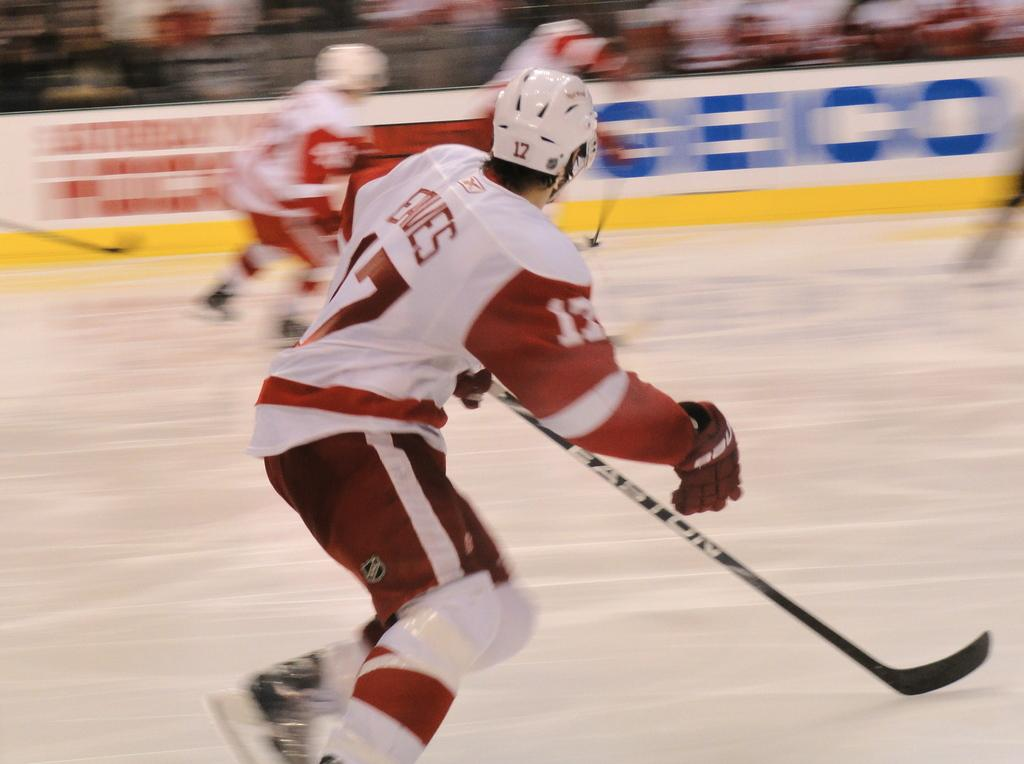What is the main subject of the image? There is a person in the image. What is the person holding in the image? The person is holding sticks. What protective gear is the person wearing? The person is wearing a helmet. What action is the person performing in the image? The person is running on the floor. What can be seen in the middle of the image? There is a fence in the middle of the image. What type of needle can be seen in the person's hand in the image? There is no needle present in the person's hand or in the image. 